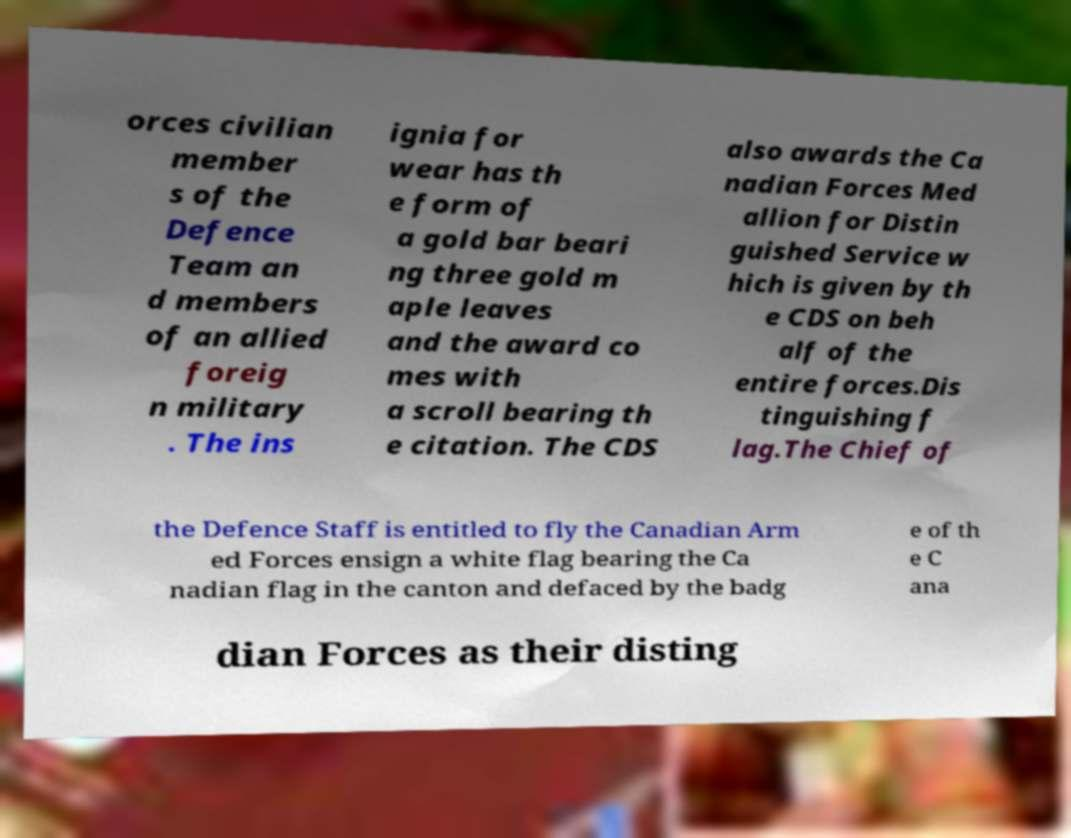I need the written content from this picture converted into text. Can you do that? orces civilian member s of the Defence Team an d members of an allied foreig n military . The ins ignia for wear has th e form of a gold bar beari ng three gold m aple leaves and the award co mes with a scroll bearing th e citation. The CDS also awards the Ca nadian Forces Med allion for Distin guished Service w hich is given by th e CDS on beh alf of the entire forces.Dis tinguishing f lag.The Chief of the Defence Staff is entitled to fly the Canadian Arm ed Forces ensign a white flag bearing the Ca nadian flag in the canton and defaced by the badg e of th e C ana dian Forces as their disting 